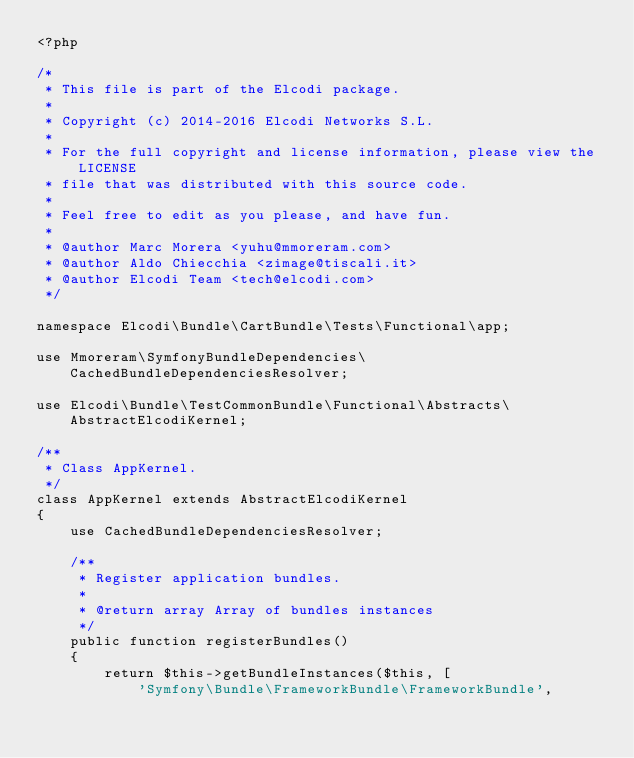<code> <loc_0><loc_0><loc_500><loc_500><_PHP_><?php

/*
 * This file is part of the Elcodi package.
 *
 * Copyright (c) 2014-2016 Elcodi Networks S.L.
 *
 * For the full copyright and license information, please view the LICENSE
 * file that was distributed with this source code.
 *
 * Feel free to edit as you please, and have fun.
 *
 * @author Marc Morera <yuhu@mmoreram.com>
 * @author Aldo Chiecchia <zimage@tiscali.it>
 * @author Elcodi Team <tech@elcodi.com>
 */

namespace Elcodi\Bundle\CartBundle\Tests\Functional\app;

use Mmoreram\SymfonyBundleDependencies\CachedBundleDependenciesResolver;

use Elcodi\Bundle\TestCommonBundle\Functional\Abstracts\AbstractElcodiKernel;

/**
 * Class AppKernel.
 */
class AppKernel extends AbstractElcodiKernel
{
    use CachedBundleDependenciesResolver;

    /**
     * Register application bundles.
     *
     * @return array Array of bundles instances
     */
    public function registerBundles()
    {
        return $this->getBundleInstances($this, [
            'Symfony\Bundle\FrameworkBundle\FrameworkBundle',</code> 